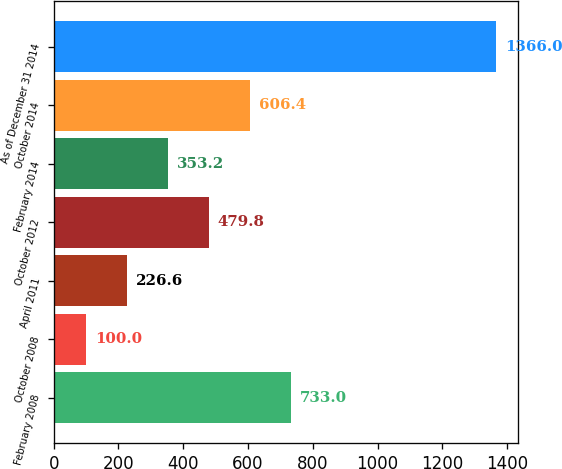Convert chart. <chart><loc_0><loc_0><loc_500><loc_500><bar_chart><fcel>February 2008<fcel>October 2008<fcel>April 2011<fcel>October 2012<fcel>February 2014<fcel>October 2014<fcel>As of December 31 2014<nl><fcel>733<fcel>100<fcel>226.6<fcel>479.8<fcel>353.2<fcel>606.4<fcel>1366<nl></chart> 